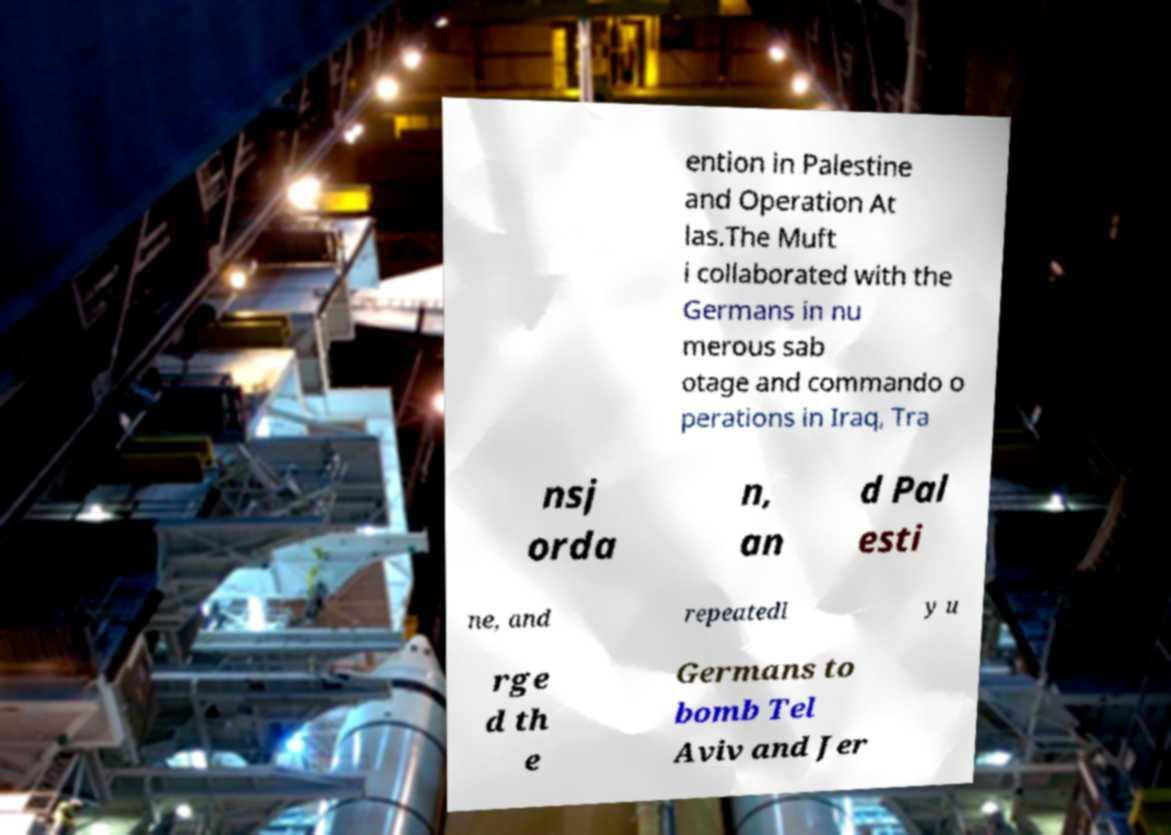Could you assist in decoding the text presented in this image and type it out clearly? ention in Palestine and Operation At las.The Muft i collaborated with the Germans in nu merous sab otage and commando o perations in Iraq, Tra nsj orda n, an d Pal esti ne, and repeatedl y u rge d th e Germans to bomb Tel Aviv and Jer 